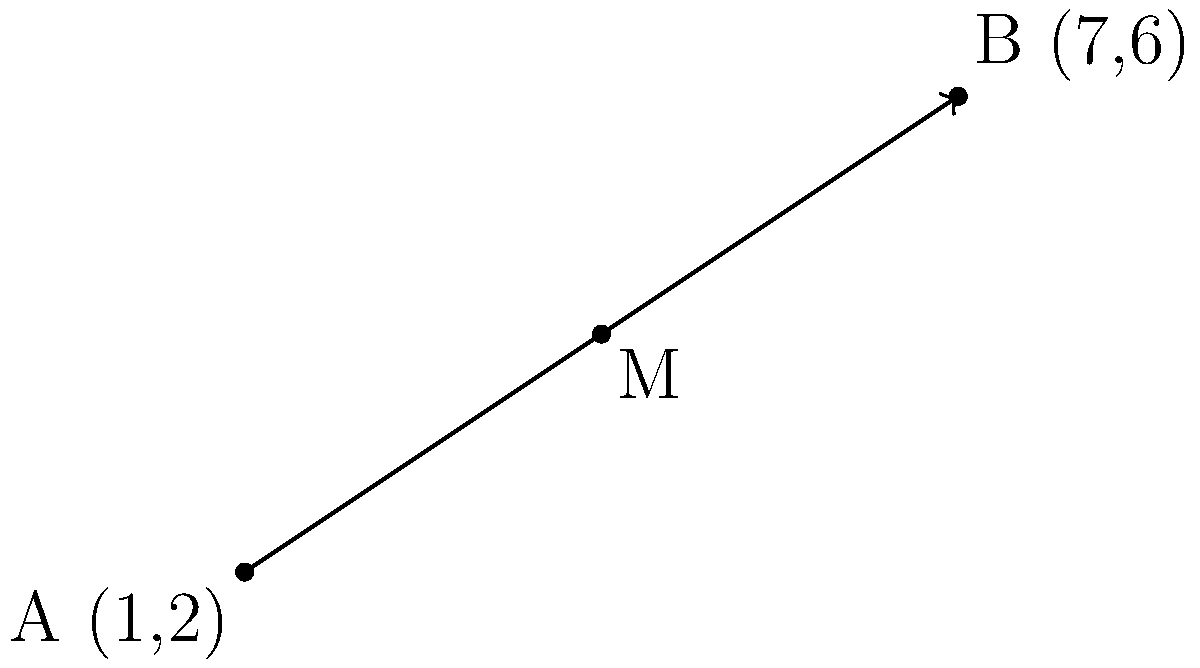As part of a new luxury handbag design, you need to determine the precise midpoint of the strap. The strap is represented by a line segment with endpoints A(1,2) and B(7,6) on a coordinate plane. Calculate the coordinates of the midpoint M of this line segment, which will be crucial for balancing the elegant design of the handbag. To find the midpoint M of the line segment AB, we can use the midpoint formula:

$$ M = (\frac{x_1 + x_2}{2}, \frac{y_1 + y_2}{2}) $$

Where $(x_1, y_1)$ are the coordinates of point A, and $(x_2, y_2)$ are the coordinates of point B.

Step 1: Identify the coordinates
A(1,2) and B(7,6)

Step 2: Apply the midpoint formula for the x-coordinate
$$ x_M = \frac{x_1 + x_2}{2} = \frac{1 + 7}{2} = \frac{8}{2} = 4 $$

Step 3: Apply the midpoint formula for the y-coordinate
$$ y_M = \frac{y_1 + y_2}{2} = \frac{2 + 6}{2} = \frac{8}{2} = 4 $$

Step 4: Combine the results
The midpoint M has coordinates (4,4).
Answer: M(4,4) 